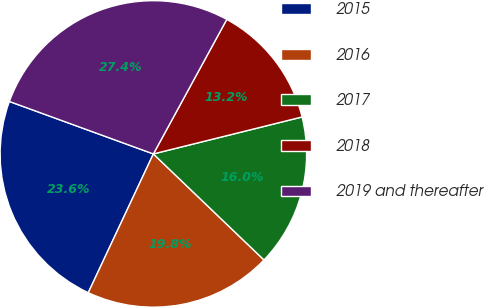<chart> <loc_0><loc_0><loc_500><loc_500><pie_chart><fcel>2015<fcel>2016<fcel>2017<fcel>2018<fcel>2019 and thereafter<nl><fcel>23.58%<fcel>19.82%<fcel>16.04%<fcel>13.17%<fcel>27.39%<nl></chart> 